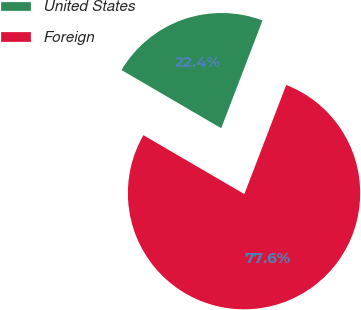Convert chart to OTSL. <chart><loc_0><loc_0><loc_500><loc_500><pie_chart><fcel>United States<fcel>Foreign<nl><fcel>22.42%<fcel>77.58%<nl></chart> 